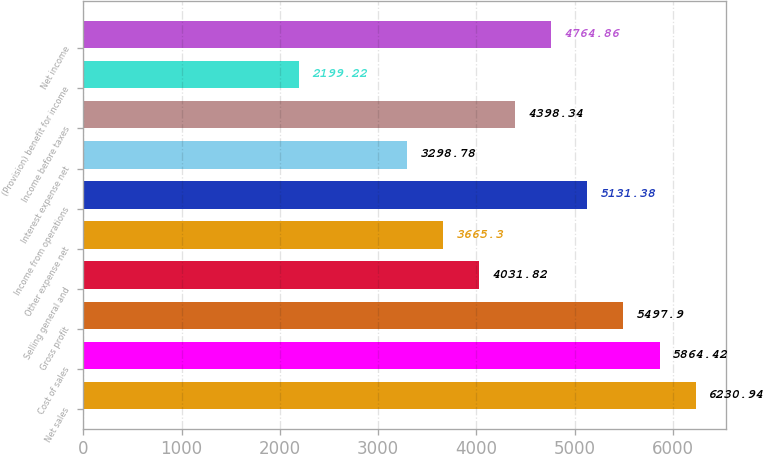<chart> <loc_0><loc_0><loc_500><loc_500><bar_chart><fcel>Net sales<fcel>Cost of sales<fcel>Gross profit<fcel>Selling general and<fcel>Other expense net<fcel>Income from operations<fcel>Interest expense net<fcel>Income before taxes<fcel>(Provision) benefit for income<fcel>Net income<nl><fcel>6230.94<fcel>5864.42<fcel>5497.9<fcel>4031.82<fcel>3665.3<fcel>5131.38<fcel>3298.78<fcel>4398.34<fcel>2199.22<fcel>4764.86<nl></chart> 